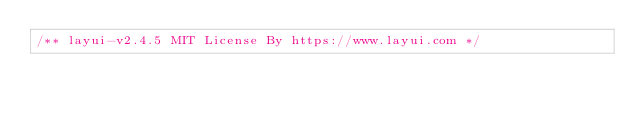<code> <loc_0><loc_0><loc_500><loc_500><_JavaScript_>/** layui-v2.4.5 MIT License By https://www.layui.com */</code> 